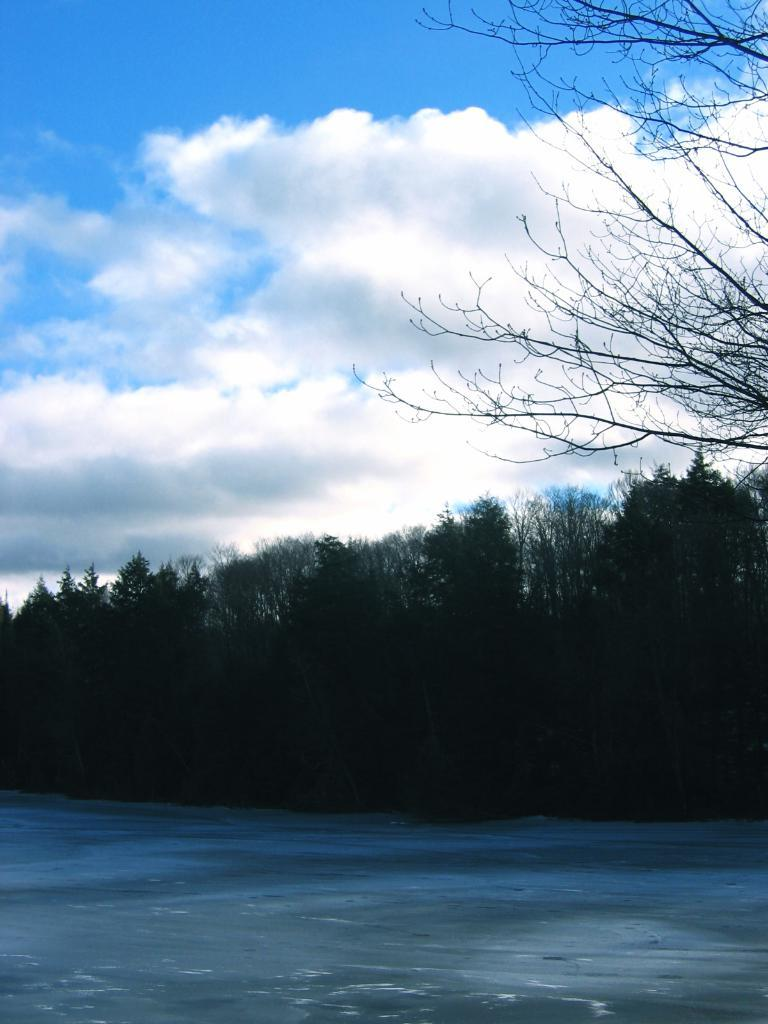What is visible in the image? Water is visible in the image. What can be seen in the background of the image? There are trees and the sky visible in the background of the image. How would you describe the sky in the image? The sky appears to be cloudy in the image. How many potatoes are floating in the water in the image? There are no potatoes present in the image; it only features water, trees, and a cloudy sky. 